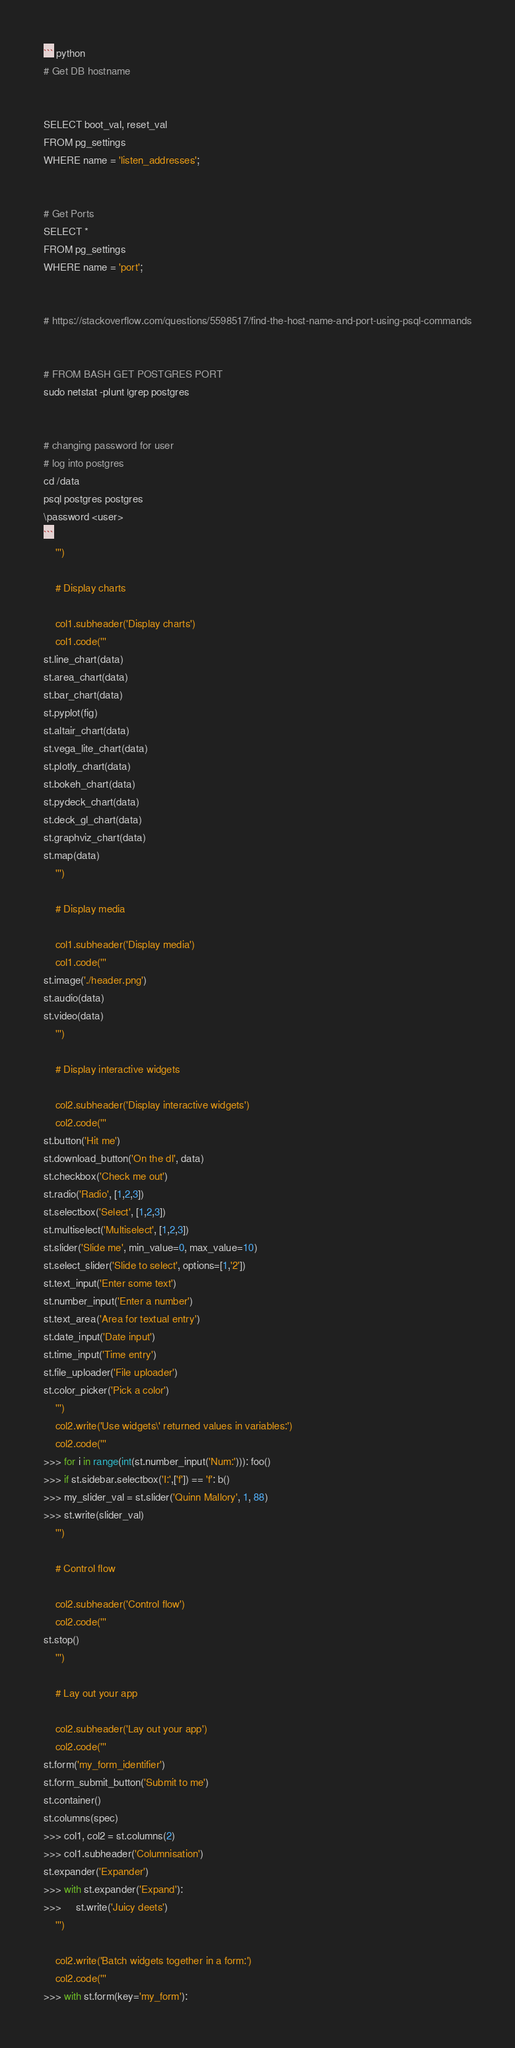<code> <loc_0><loc_0><loc_500><loc_500><_Python_>``` python
# Get DB hostname


SELECT boot_val, reset_val
FROM pg_settings
WHERE name = 'listen_addresses';


# Get Ports
SELECT *
FROM pg_settings
WHERE name = 'port';


# https://stackoverflow.com/questions/5598517/find-the-host-name-and-port-using-psql-commands


# FROM BASH GET POSTGRES PORT
sudo netstat -plunt |grep postgres


# changing password for user
# log into postgres
cd /data
psql postgres postgres
\password <user>
```
    ''')

    # Display charts

    col1.subheader('Display charts')
    col1.code('''
st.line_chart(data)
st.area_chart(data)
st.bar_chart(data)
st.pyplot(fig)
st.altair_chart(data)
st.vega_lite_chart(data)
st.plotly_chart(data)
st.bokeh_chart(data)
st.pydeck_chart(data)
st.deck_gl_chart(data)
st.graphviz_chart(data)
st.map(data)
    ''')

    # Display media

    col1.subheader('Display media')
    col1.code('''
st.image('./header.png')
st.audio(data)
st.video(data)
    ''')

    # Display interactive widgets

    col2.subheader('Display interactive widgets')
    col2.code('''
st.button('Hit me')
st.download_button('On the dl', data)
st.checkbox('Check me out')
st.radio('Radio', [1,2,3])
st.selectbox('Select', [1,2,3])
st.multiselect('Multiselect', [1,2,3])
st.slider('Slide me', min_value=0, max_value=10)
st.select_slider('Slide to select', options=[1,'2'])
st.text_input('Enter some text')
st.number_input('Enter a number')
st.text_area('Area for textual entry')
st.date_input('Date input')
st.time_input('Time entry')
st.file_uploader('File uploader')
st.color_picker('Pick a color')
    ''')
    col2.write('Use widgets\' returned values in variables:')
    col2.code('''
>>> for i in range(int(st.number_input('Num:'))): foo()
>>> if st.sidebar.selectbox('I:',['f']) == 'f': b()
>>> my_slider_val = st.slider('Quinn Mallory', 1, 88)
>>> st.write(slider_val)
    ''')

    # Control flow

    col2.subheader('Control flow')
    col2.code('''
st.stop()
    ''')

    # Lay out your app

    col2.subheader('Lay out your app')
    col2.code('''
st.form('my_form_identifier')
st.form_submit_button('Submit to me')
st.container()
st.columns(spec)
>>> col1, col2 = st.columns(2)
>>> col1.subheader('Columnisation')
st.expander('Expander')
>>> with st.expander('Expand'):
>>>     st.write('Juicy deets')
    ''')

    col2.write('Batch widgets together in a form:')
    col2.code('''
>>> with st.form(key='my_form'):</code> 